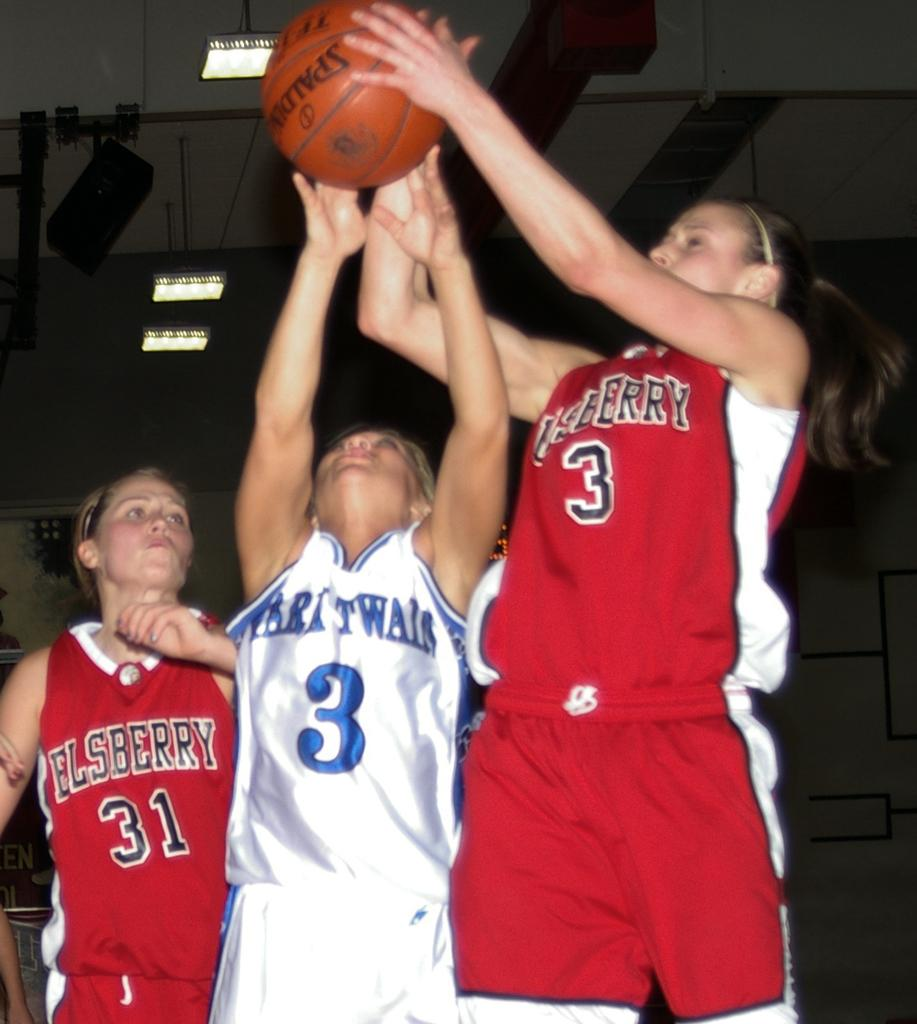<image>
Describe the image concisely. Number 3 for Elsberry takes the rebound over the oppostion's number 3. 